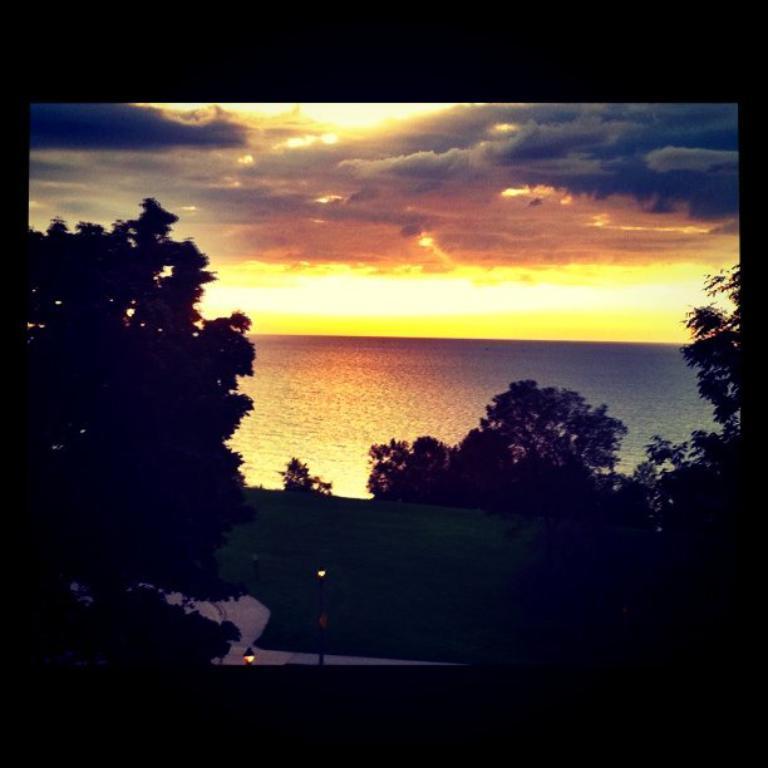Can you describe this image briefly? In this image in the center there are some trees and at the bottom there is walkway grass, and in the background there is a river and at the top of the image there is sky. 